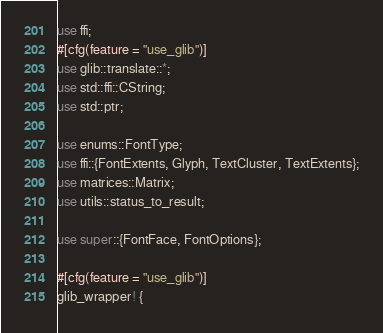<code> <loc_0><loc_0><loc_500><loc_500><_Rust_>use ffi;
#[cfg(feature = "use_glib")]
use glib::translate::*;
use std::ffi::CString;
use std::ptr;

use enums::FontType;
use ffi::{FontExtents, Glyph, TextCluster, TextExtents};
use matrices::Matrix;
use utils::status_to_result;

use super::{FontFace, FontOptions};

#[cfg(feature = "use_glib")]
glib_wrapper! {</code> 